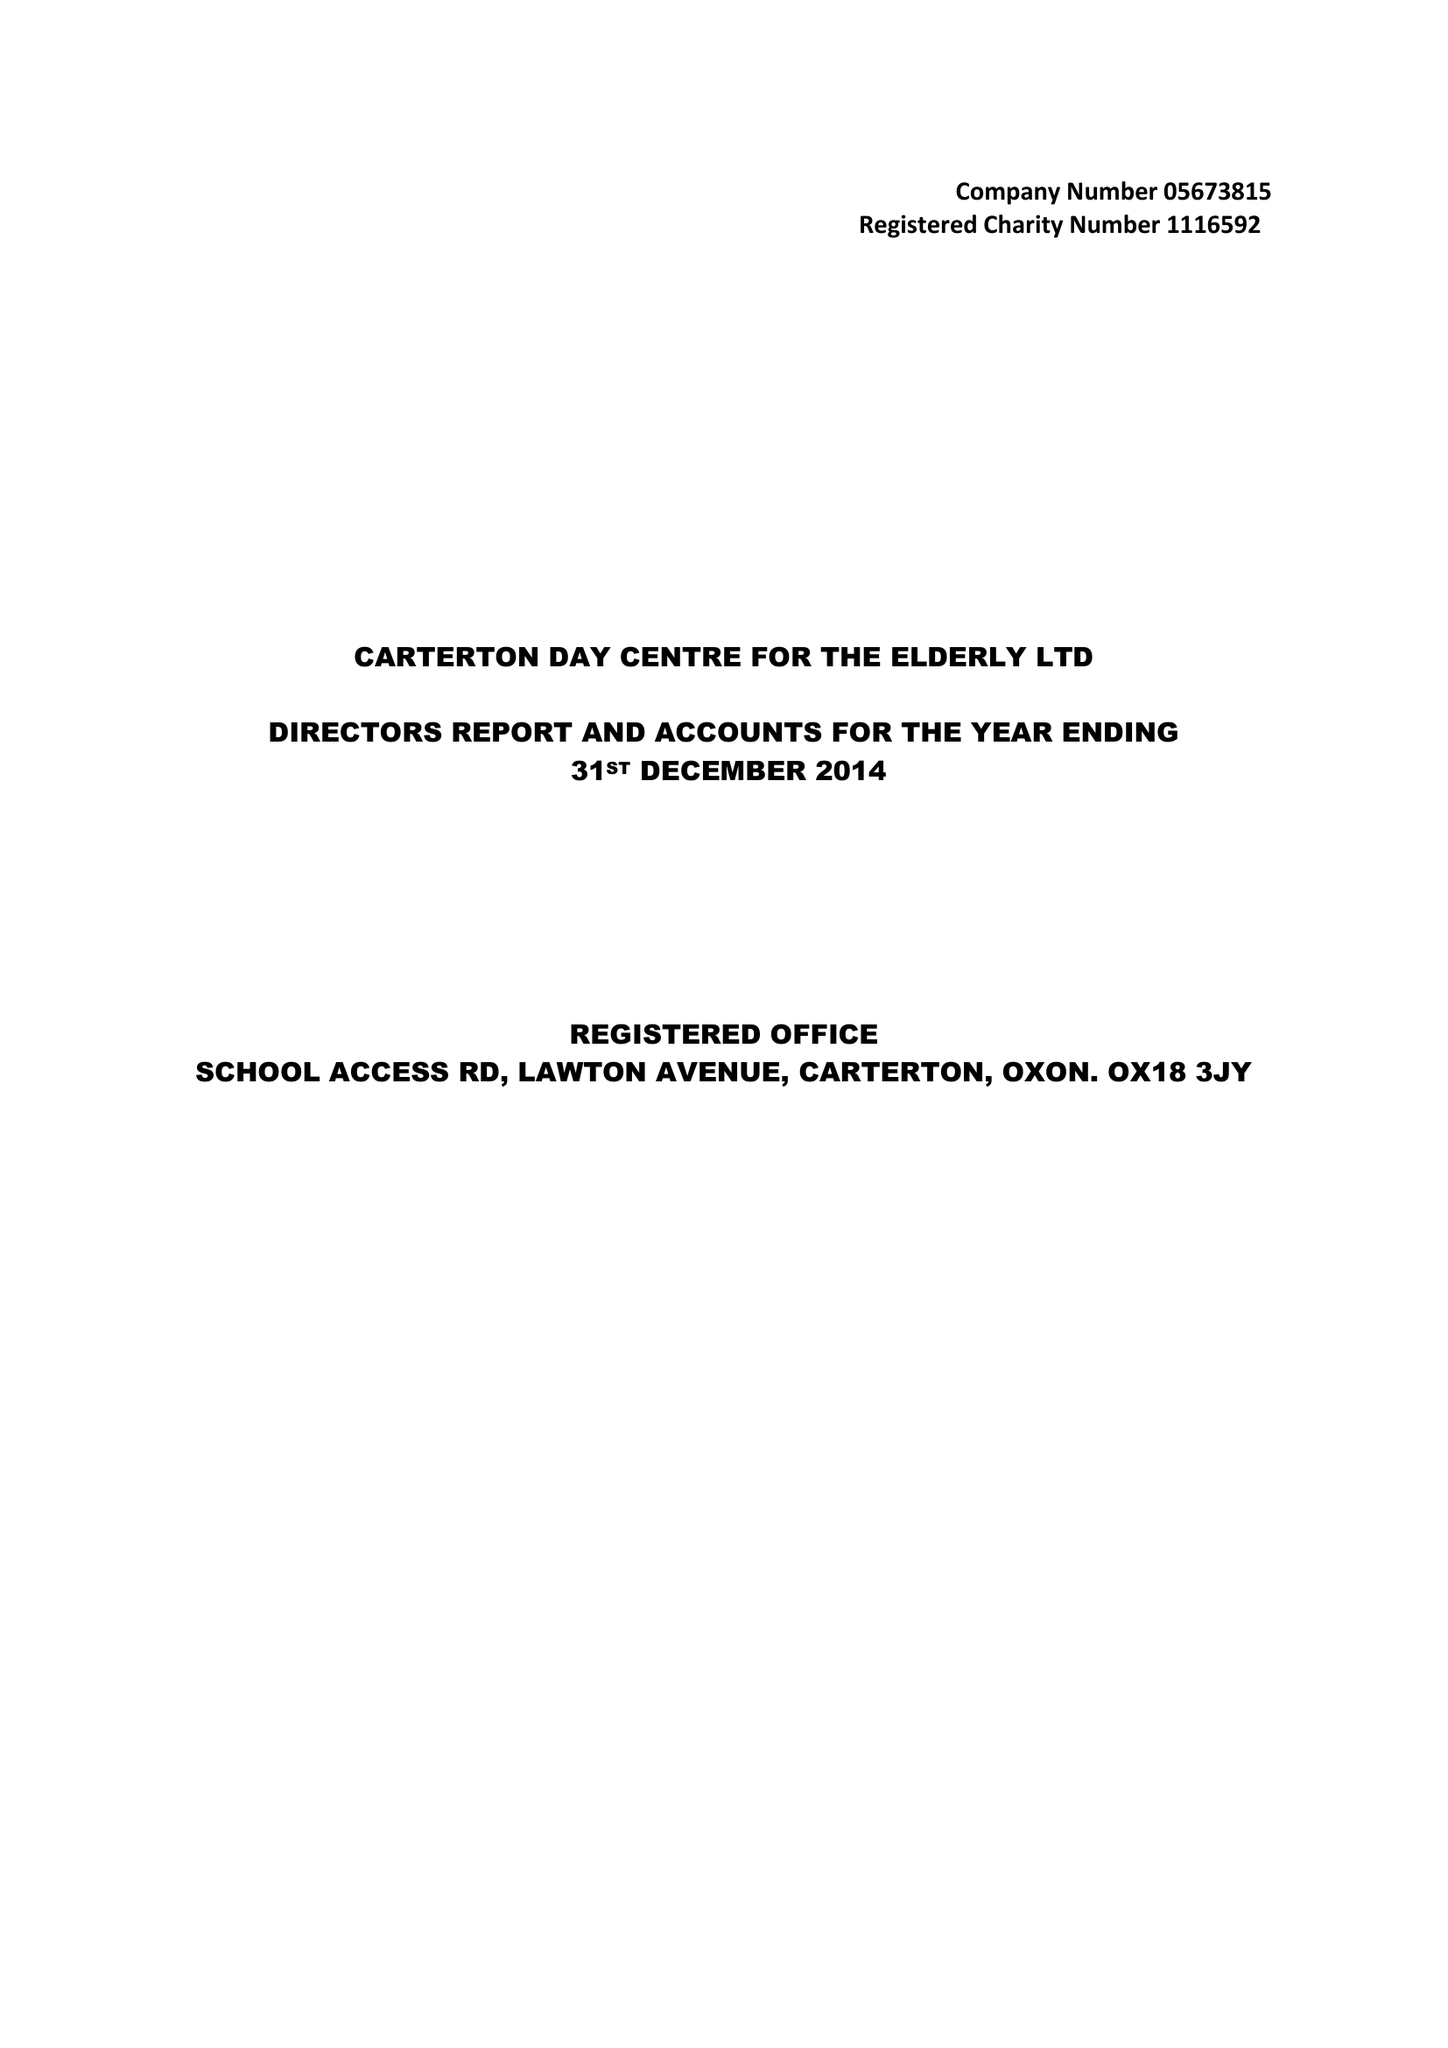What is the value for the address__post_town?
Answer the question using a single word or phrase. CARTERTON 